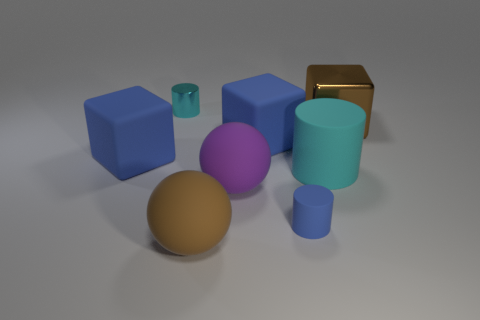What could be the purpose of this collection of objects? This assortment of objects could serve various purposes; it may be a simple visual study of geometric shapes, a scene from a 3D modeling software demonstration, or perhaps an abstract artistic composition.  Is there any indication of size or scale in this image? There are no definitive indicators of size or scale, such as familiar objects or measurements, to gauge the actual dimensions of the shapes, leaving their sizes ambiguous. 